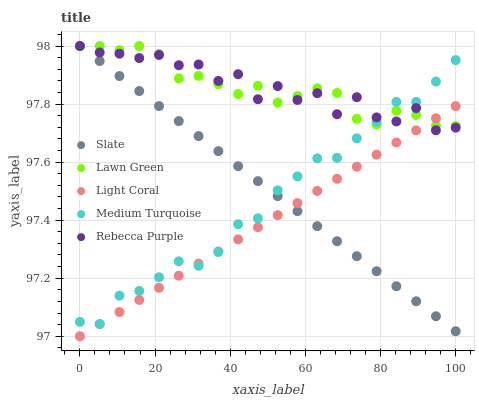Does Light Coral have the minimum area under the curve?
Answer yes or no. Yes. Does Rebecca Purple have the maximum area under the curve?
Answer yes or no. Yes. Does Lawn Green have the minimum area under the curve?
Answer yes or no. No. Does Lawn Green have the maximum area under the curve?
Answer yes or no. No. Is Slate the smoothest?
Answer yes or no. Yes. Is Rebecca Purple the roughest?
Answer yes or no. Yes. Is Lawn Green the smoothest?
Answer yes or no. No. Is Lawn Green the roughest?
Answer yes or no. No. Does Light Coral have the lowest value?
Answer yes or no. Yes. Does Slate have the lowest value?
Answer yes or no. No. Does Rebecca Purple have the highest value?
Answer yes or no. Yes. Does Medium Turquoise have the highest value?
Answer yes or no. No. Does Rebecca Purple intersect Medium Turquoise?
Answer yes or no. Yes. Is Rebecca Purple less than Medium Turquoise?
Answer yes or no. No. Is Rebecca Purple greater than Medium Turquoise?
Answer yes or no. No. 